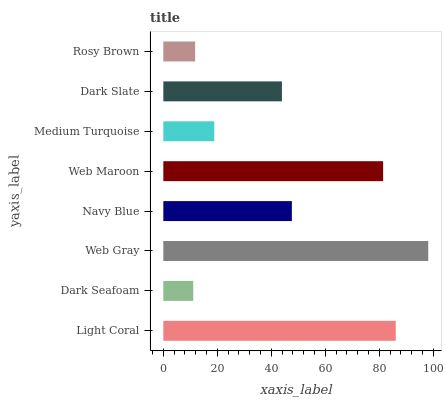Is Dark Seafoam the minimum?
Answer yes or no. Yes. Is Web Gray the maximum?
Answer yes or no. Yes. Is Web Gray the minimum?
Answer yes or no. No. Is Dark Seafoam the maximum?
Answer yes or no. No. Is Web Gray greater than Dark Seafoam?
Answer yes or no. Yes. Is Dark Seafoam less than Web Gray?
Answer yes or no. Yes. Is Dark Seafoam greater than Web Gray?
Answer yes or no. No. Is Web Gray less than Dark Seafoam?
Answer yes or no. No. Is Navy Blue the high median?
Answer yes or no. Yes. Is Dark Slate the low median?
Answer yes or no. Yes. Is Light Coral the high median?
Answer yes or no. No. Is Rosy Brown the low median?
Answer yes or no. No. 